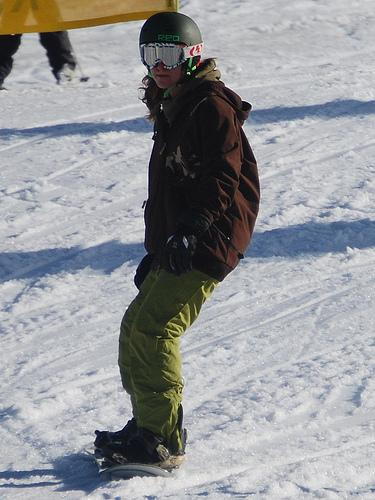Summarize the scene in the image in a single sentence. A woman snowboarding down a snowy hill wearing a brown jacket, green pants, black gloves, safety helmet, and goggles, with a yellow sign in the vicinity. Describe the surrounding environment in the image. The snowy environment looks chilly and serene, with tracks, shadows, and a yellow sign in the snow creating an interesting landscape. Craft a three-word descriptive phrase for the picture. Snowy Adventure Awaits. Imagine this picture is part of a story. Briefly describe the scene where this picture takes place. On a snowy hill, the female protagonist expertly glides down the slope, leaving tracks in the snow as she moves past a mysterious yellow sign, embracing her love for adventure. List five distinct features of the snowboarder's appearance and attire. Brown winter jacket, green snow pants, black helmet, ski goggles, long curly hair. Create a haiku (5-7-5 syllable pattern) about the subject of the photo. Yellow sign stands by. Provide a brief caption for this image related to winter sports. Riding the snow waves: a fearless snowboarder takes on the icy slopes! Write a creative sentence describing an action in the photo. The woman's hair flows freely like a banner as she becomes one with her snowboard, conquering the frosty landscape. Describe the female snowboarder's outfit and gear in detail. The snowboarder wears an olive green snow pants with side zipper, brown hooded winter jacket with camo pocket, black and white gloves, black safety helmet with green strap, and ski goggles with white and red strap. Using a descriptive language, narrate the overall aesthetic of the photo. The contrast between the sparkling white snow and the array of colorful garments donned by the female snowboarder creates a lively and adventurous visual experience. 